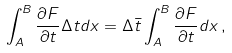Convert formula to latex. <formula><loc_0><loc_0><loc_500><loc_500>\int _ { A } ^ { B } \frac { \partial F } { \partial t } \Delta t d x = \Delta \bar { t } \int _ { A } ^ { B } \frac { \partial F } { \partial t } d x \, ,</formula> 